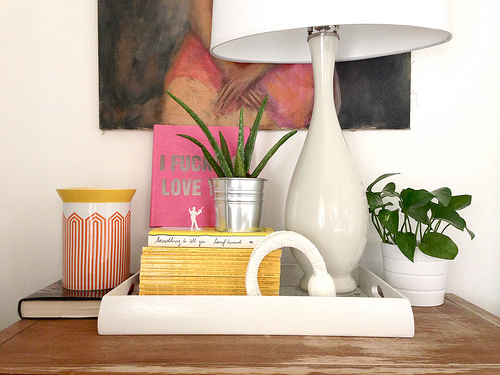<image>
Can you confirm if the lamp is next to the plant? Yes. The lamp is positioned adjacent to the plant, located nearby in the same general area. 